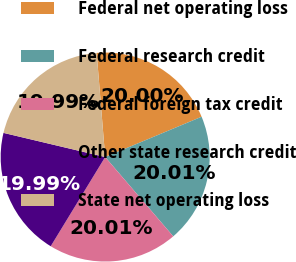Convert chart. <chart><loc_0><loc_0><loc_500><loc_500><pie_chart><fcel>Federal net operating loss<fcel>Federal research credit<fcel>Federal foreign tax credit<fcel>Other state research credit<fcel>State net operating loss<nl><fcel>20.0%<fcel>20.01%<fcel>20.01%<fcel>19.99%<fcel>19.99%<nl></chart> 